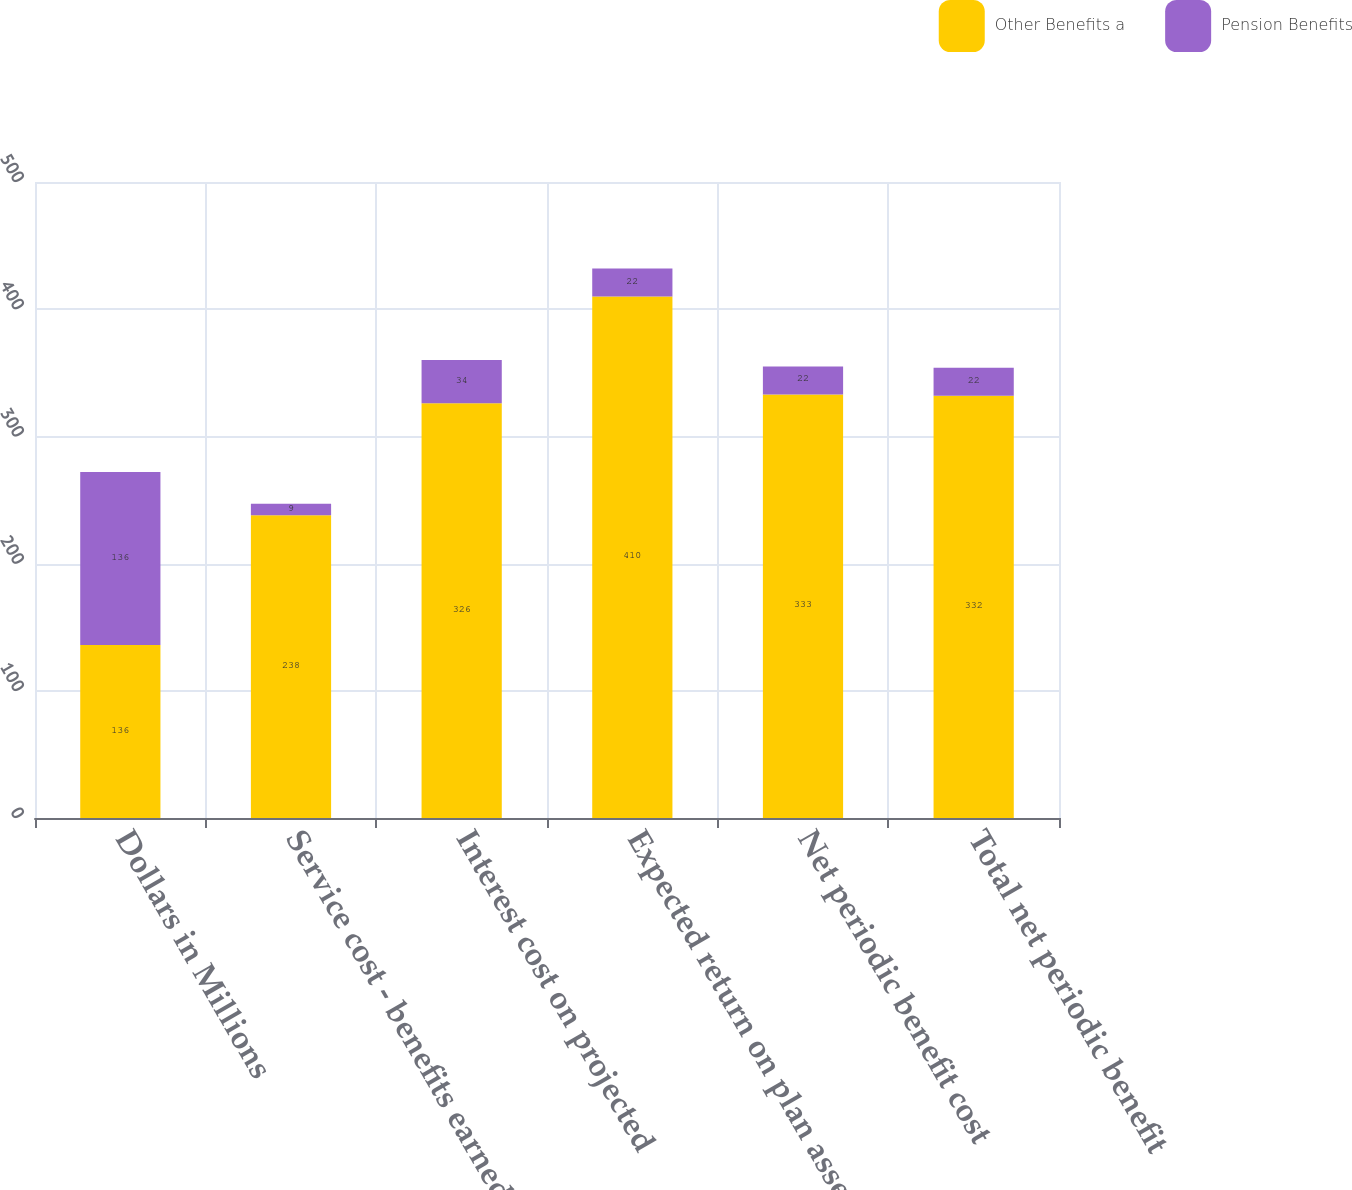Convert chart. <chart><loc_0><loc_0><loc_500><loc_500><stacked_bar_chart><ecel><fcel>Dollars in Millions<fcel>Service cost - benefits earned<fcel>Interest cost on projected<fcel>Expected return on plan assets<fcel>Net periodic benefit cost<fcel>Total net periodic benefit<nl><fcel>Other Benefits a<fcel>136<fcel>238<fcel>326<fcel>410<fcel>333<fcel>332<nl><fcel>Pension Benefits<fcel>136<fcel>9<fcel>34<fcel>22<fcel>22<fcel>22<nl></chart> 